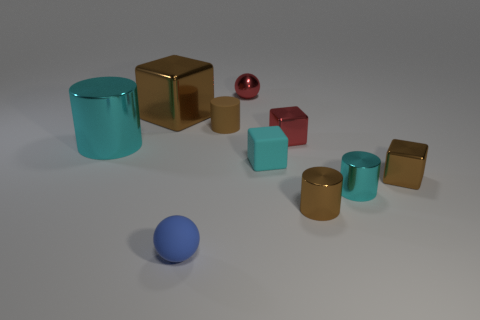Subtract 1 cylinders. How many cylinders are left? 3 Subtract all spheres. How many objects are left? 8 Add 8 large brown cubes. How many large brown cubes are left? 9 Add 1 gray balls. How many gray balls exist? 1 Subtract 0 brown balls. How many objects are left? 10 Subtract all small blue things. Subtract all large brown shiny blocks. How many objects are left? 8 